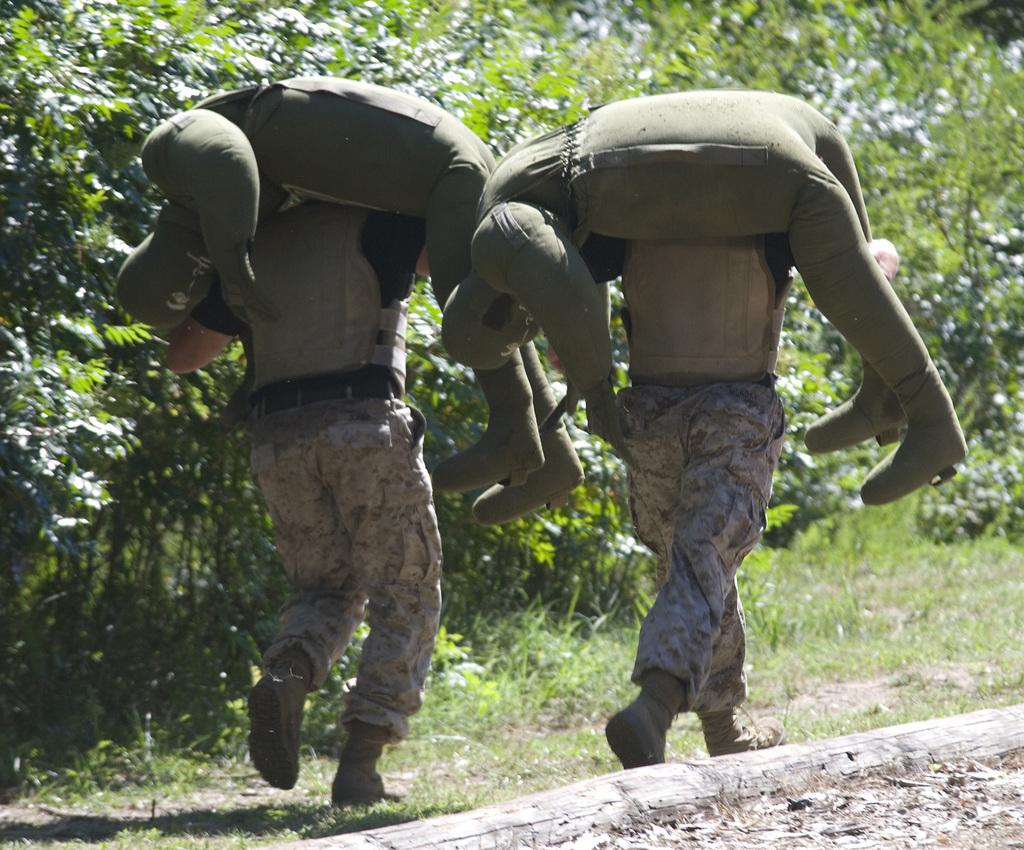How many people are in the image? There are two people in the image. What are the two people doing in the image? The two people are carrying an object on their shoulders. What does the object they are carrying resemble? The object they are carrying looks like a person. What can be seen in the background of the image? There are trees and grass in the background of the image. What type of book is the person reading in the image? There is no person reading a book in the image; the two people are carrying an object that resembles a person. How many pets are visible in the image? There are no pets visible in the image. 